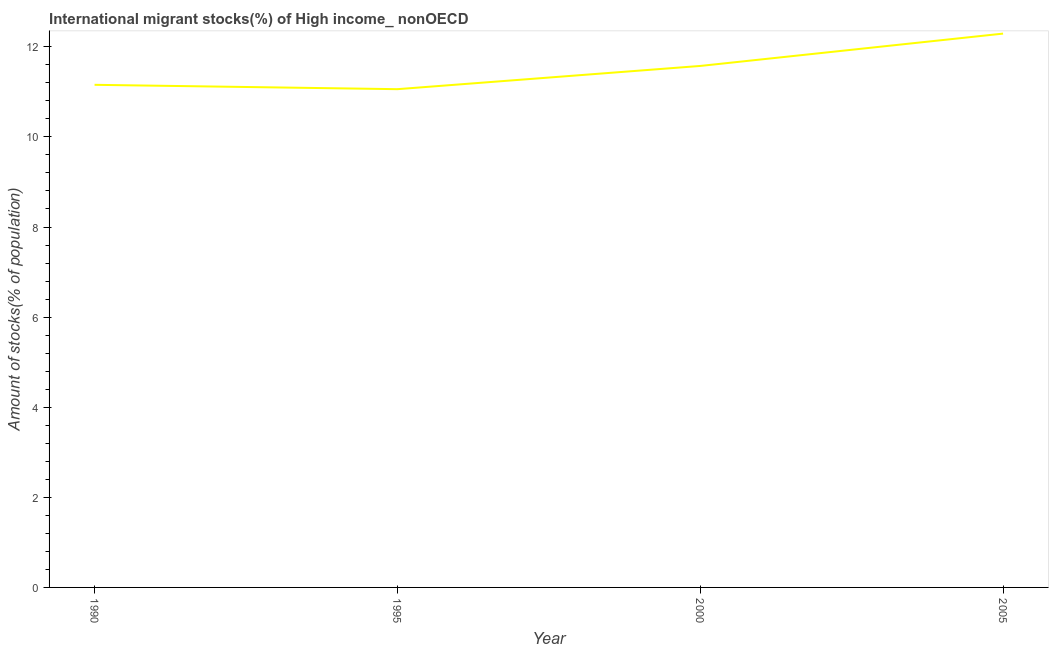What is the number of international migrant stocks in 2000?
Ensure brevity in your answer.  11.58. Across all years, what is the maximum number of international migrant stocks?
Your answer should be compact. 12.29. Across all years, what is the minimum number of international migrant stocks?
Keep it short and to the point. 11.06. In which year was the number of international migrant stocks maximum?
Keep it short and to the point. 2005. What is the sum of the number of international migrant stocks?
Offer a very short reply. 46.08. What is the difference between the number of international migrant stocks in 1990 and 1995?
Provide a short and direct response. 0.1. What is the average number of international migrant stocks per year?
Your response must be concise. 11.52. What is the median number of international migrant stocks?
Ensure brevity in your answer.  11.37. What is the ratio of the number of international migrant stocks in 1990 to that in 2005?
Your answer should be very brief. 0.91. What is the difference between the highest and the second highest number of international migrant stocks?
Your answer should be compact. 0.72. Is the sum of the number of international migrant stocks in 1995 and 2005 greater than the maximum number of international migrant stocks across all years?
Your response must be concise. Yes. What is the difference between the highest and the lowest number of international migrant stocks?
Provide a short and direct response. 1.23. Does the number of international migrant stocks monotonically increase over the years?
Your answer should be compact. No. How many lines are there?
Keep it short and to the point. 1. Are the values on the major ticks of Y-axis written in scientific E-notation?
Ensure brevity in your answer.  No. Does the graph contain any zero values?
Offer a terse response. No. Does the graph contain grids?
Keep it short and to the point. No. What is the title of the graph?
Make the answer very short. International migrant stocks(%) of High income_ nonOECD. What is the label or title of the X-axis?
Your answer should be compact. Year. What is the label or title of the Y-axis?
Offer a terse response. Amount of stocks(% of population). What is the Amount of stocks(% of population) in 1990?
Your answer should be very brief. 11.16. What is the Amount of stocks(% of population) of 1995?
Your response must be concise. 11.06. What is the Amount of stocks(% of population) of 2000?
Your answer should be very brief. 11.58. What is the Amount of stocks(% of population) in 2005?
Ensure brevity in your answer.  12.29. What is the difference between the Amount of stocks(% of population) in 1990 and 1995?
Keep it short and to the point. 0.1. What is the difference between the Amount of stocks(% of population) in 1990 and 2000?
Your response must be concise. -0.42. What is the difference between the Amount of stocks(% of population) in 1990 and 2005?
Your answer should be very brief. -1.14. What is the difference between the Amount of stocks(% of population) in 1995 and 2000?
Provide a short and direct response. -0.52. What is the difference between the Amount of stocks(% of population) in 1995 and 2005?
Your answer should be very brief. -1.23. What is the difference between the Amount of stocks(% of population) in 2000 and 2005?
Offer a very short reply. -0.72. What is the ratio of the Amount of stocks(% of population) in 1990 to that in 1995?
Your answer should be compact. 1.01. What is the ratio of the Amount of stocks(% of population) in 1990 to that in 2000?
Provide a succinct answer. 0.96. What is the ratio of the Amount of stocks(% of population) in 1990 to that in 2005?
Your answer should be very brief. 0.91. What is the ratio of the Amount of stocks(% of population) in 1995 to that in 2000?
Provide a short and direct response. 0.95. What is the ratio of the Amount of stocks(% of population) in 2000 to that in 2005?
Your answer should be very brief. 0.94. 